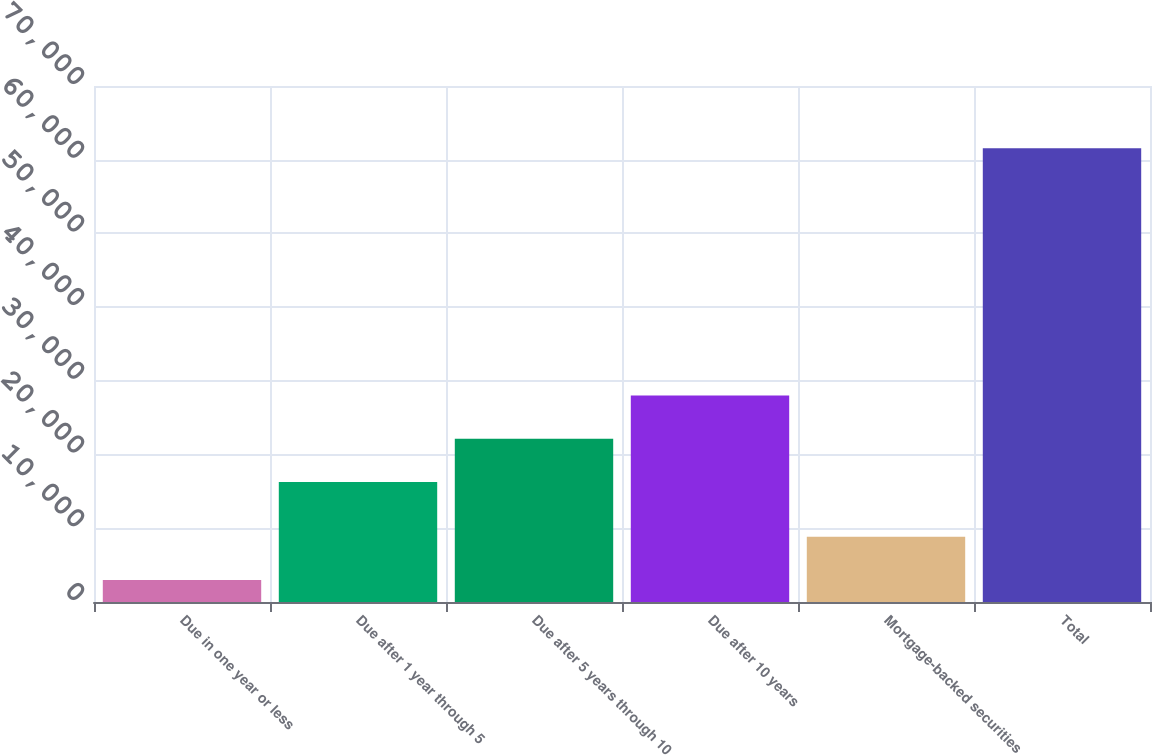<chart> <loc_0><loc_0><loc_500><loc_500><bar_chart><fcel>Due in one year or less<fcel>Due after 1 year through 5<fcel>Due after 5 years through 10<fcel>Due after 10 years<fcel>Mortgage-backed securities<fcel>Total<nl><fcel>2982<fcel>16285<fcel>22143.7<fcel>28002.4<fcel>8840.7<fcel>61569<nl></chart> 